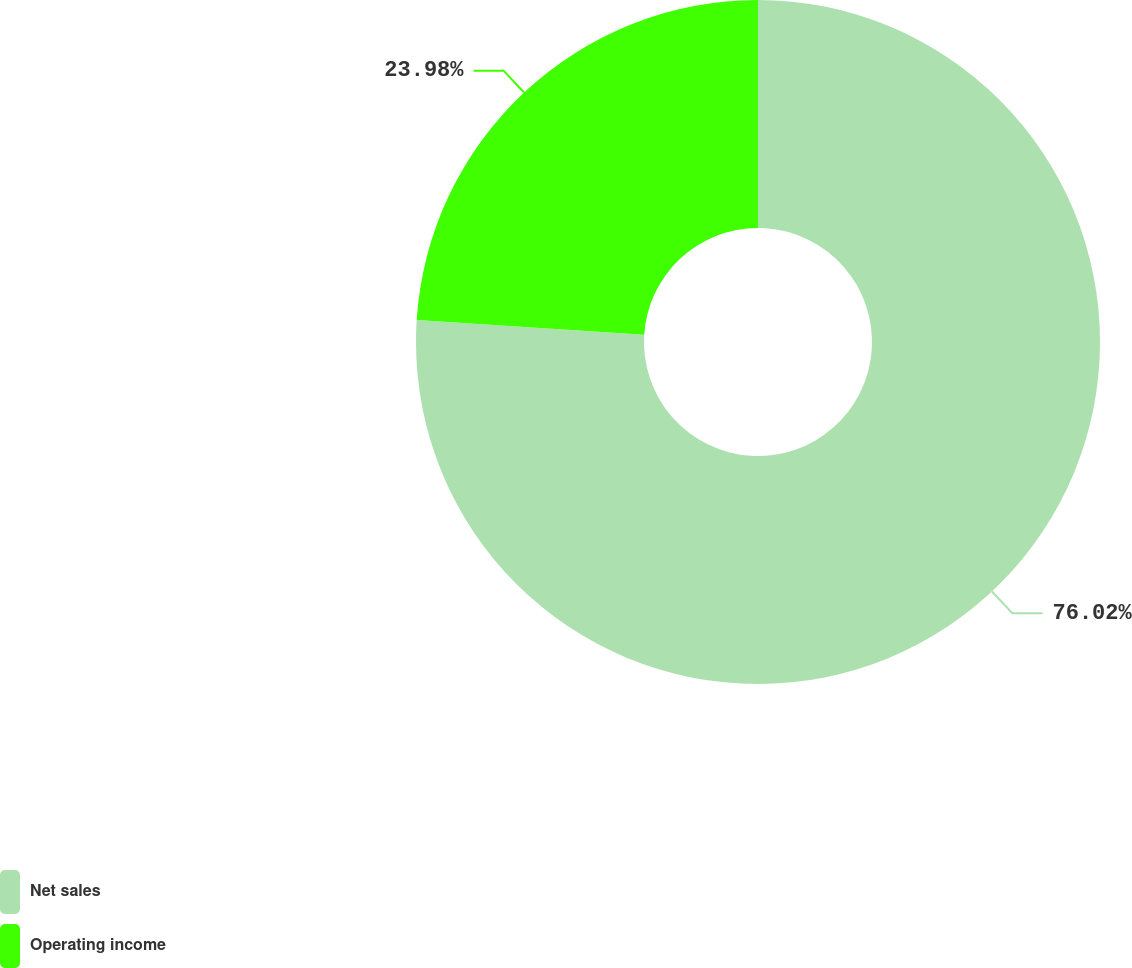Convert chart to OTSL. <chart><loc_0><loc_0><loc_500><loc_500><pie_chart><fcel>Net sales<fcel>Operating income<nl><fcel>76.02%<fcel>23.98%<nl></chart> 